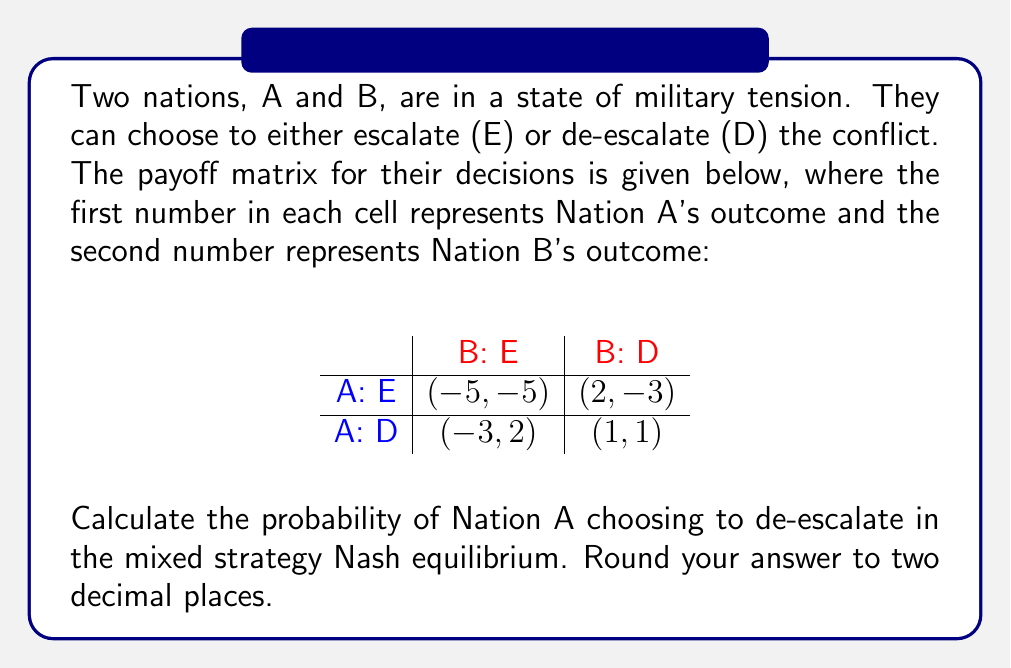Show me your answer to this math problem. To solve this problem using game theory, we'll follow these steps:

1) In a mixed strategy Nash equilibrium, each player must be indifferent between their pure strategies. Let's denote the probability of Nation B choosing to escalate as $p$.

2) For Nation A to be indifferent between escalating and de-escalating:

   $-5p + 2(1-p) = -3p + 1(1-p)$

3) Simplify the equation:

   $-5p + 2 - 2p = -3p + 1 - p$
   $-7p + 2 = -4p + 1$

4) Solve for $p$:

   $-3p = -1$
   $p = \frac{1}{3}$

5) Now that we know Nation B's strategy, we can calculate Nation A's strategy. Let $q$ be the probability of Nation A choosing to de-escalate.

6) For Nation B to be indifferent:

   $-5q + 2(1-q) = -3q + 1(1-q)$

7) Simplify and solve:

   $-5q + 2 - 2q = -3q + 1 - q$
   $-7q + 2 = -4q + 1$
   $-3q = -1$
   $q = \frac{1}{3}$

8) Therefore, the probability of Nation A choosing to de-escalate is $\frac{1}{3}$ or approximately 0.33.
Answer: 0.33 